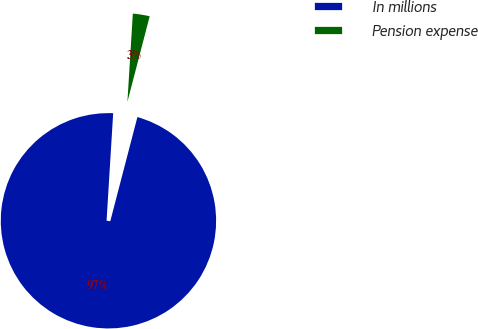<chart> <loc_0><loc_0><loc_500><loc_500><pie_chart><fcel>In millions<fcel>Pension expense<nl><fcel>96.92%<fcel>3.08%<nl></chart> 